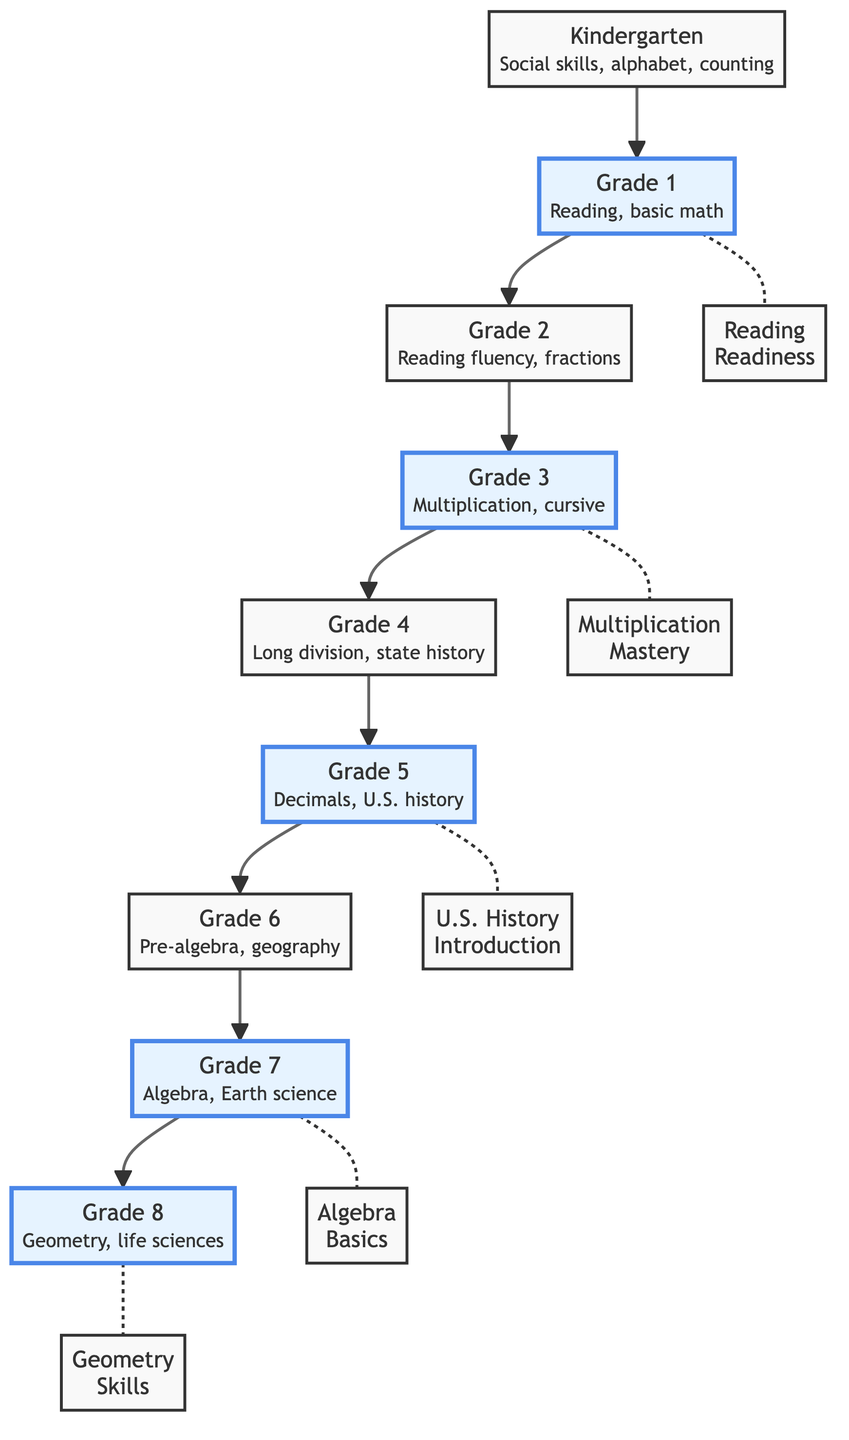What grade level introduces cursive writing? In the diagram, cursive writing is introduced in Grade 3, as indicated by the description under that node.
Answer: Grade 3 Which two grades have reading milestones? The milestone nodes connected to Grade 1 and Grade 3 indicate that reading is a significant part of the curriculum at those levels.
Answer: Grade 1 and Grade 3 How many key educational milestones are highlighted in the diagram? By counting the milestone nodes, there are a total of five key educational milestones highlighted throughout the diagram.
Answer: 5 What is the relationship between Grade 5 and U.S. history? The diagram shows that Grade 5 includes an introduction to U.S. history, indicated by the milestone node connected to Grade 5.
Answer: Introduction Which grade follows Grade 6? The flowchart shows a direct path leading from Grade 6 to Grade 7, confirming the sequence of grades in the curriculum.
Answer: Grade 7 Which subject is taught in Grade 4? The description under Grade 4 specifies the subjects taught, which include long division and state history.
Answer: Long division, state history What milestone is associated with Grade 7? According to the diagram, Grade 7 has a milestone associated with the basics of algebra, indicating a key learning objective for that grade.
Answer: Algebra Basics What are the subjects taught in Kindergarten? The diagram specifies that Kindergarten focuses on social skills, the alphabet, and counting, outlining what is prioritized at that grade level.
Answer: Social skills, alphabet, counting 